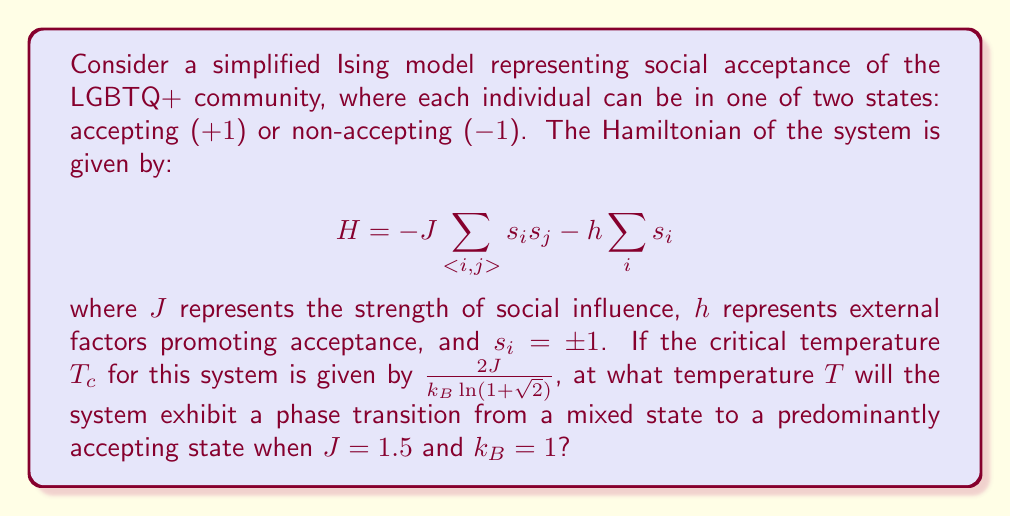Solve this math problem. To solve this problem, we'll follow these steps:

1) The critical temperature $T_c$ for the 2D Ising model is given by:

   $$T_c = \frac{2J}{k_B \ln(1+\sqrt{2})}$$

2) We're given that $J = 1.5$ and $k_B = 1$. Let's substitute these values:

   $$T_c = \frac{2(1.5)}{1 \cdot \ln(1+\sqrt{2})}$$

3) Simplify:

   $$T_c = \frac{3}{\ln(1+\sqrt{2})}$$

4) Calculate $\ln(1+\sqrt{2})$:

   $$\ln(1+\sqrt{2}) \approx 0.8813736$$

5) Now we can calculate $T_c$:

   $$T_c = \frac{3}{0.8813736} \approx 3.4040$$

6) At this temperature, the system will transition from a disordered (mixed) state to an ordered state. In the context of our model, this represents a shift from a mixed acceptance state to a predominantly accepting state.

The phase transition occurs at this critical temperature $T_c$.
Answer: $T \approx 3.4040$ 